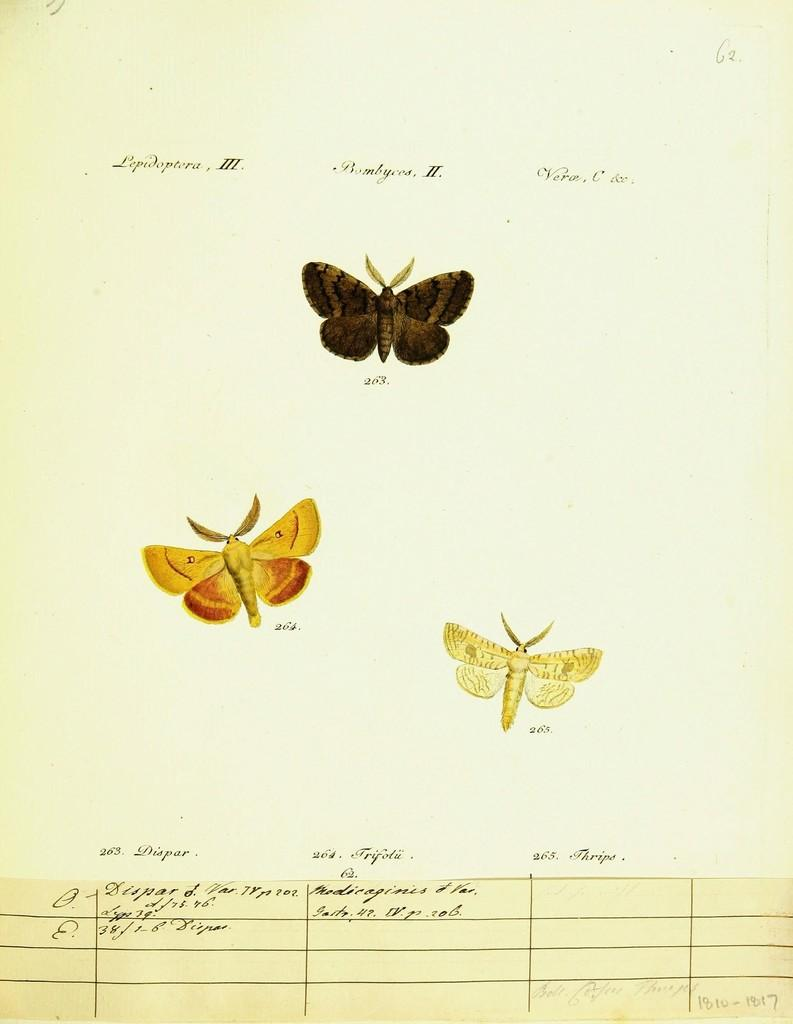What type of living organisms can be seen in the picture? There are images of butterflies in the picture. What else is present in the picture besides the butterflies? There is text on a paper in the picture. What type of property is visible in the image? There is no property visible in the image; it features images of butterflies and text on a paper. What degree of education does the robin in the image possess? There is no robin present in the image, so it is not possible to determine its level of education. 